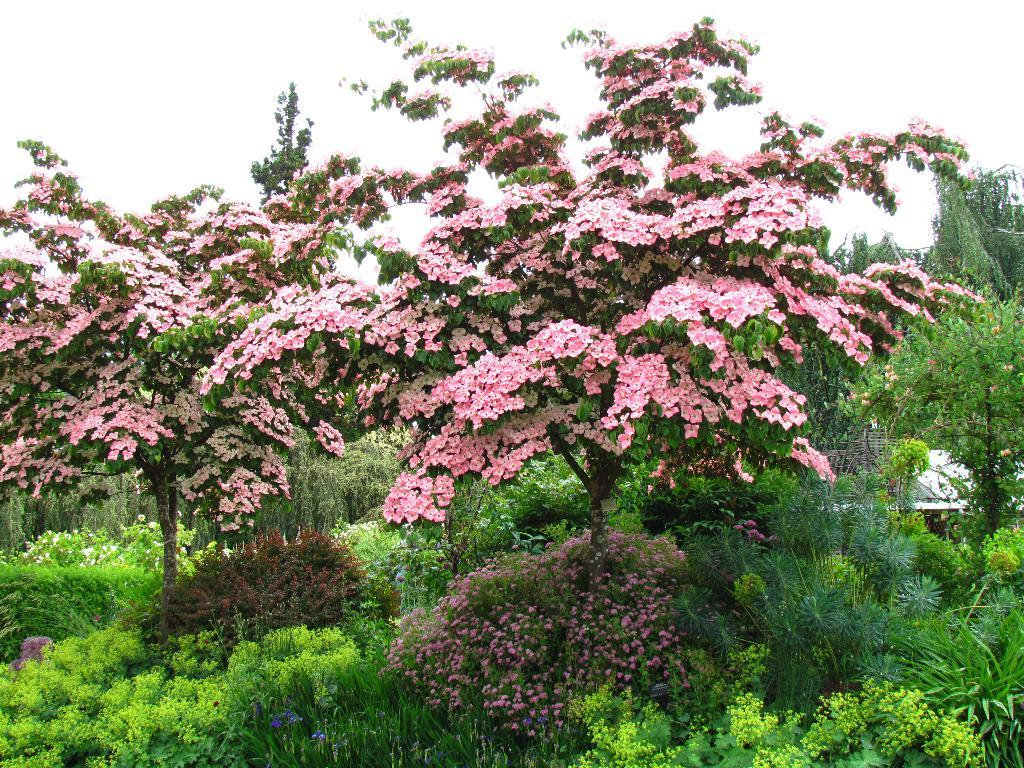What type of vegetation can be seen in the image? There are trees, plants, and grass in the image. What color are the flowers on the tree? The flowers on the tree are pink. What is visible at the top of the image? The sky is visible at the top of the image. What can be seen in the sky? Clouds are present in the sky. What is located on the left side of the image? There is a white color object on the left side of the image. What is the value of the snow in the image? There is no snow present in the image, so it is not possible to determine its value. What type of destruction can be seen in the image? There is no destruction present in the image; it features trees, plants, grass, and a white object. 